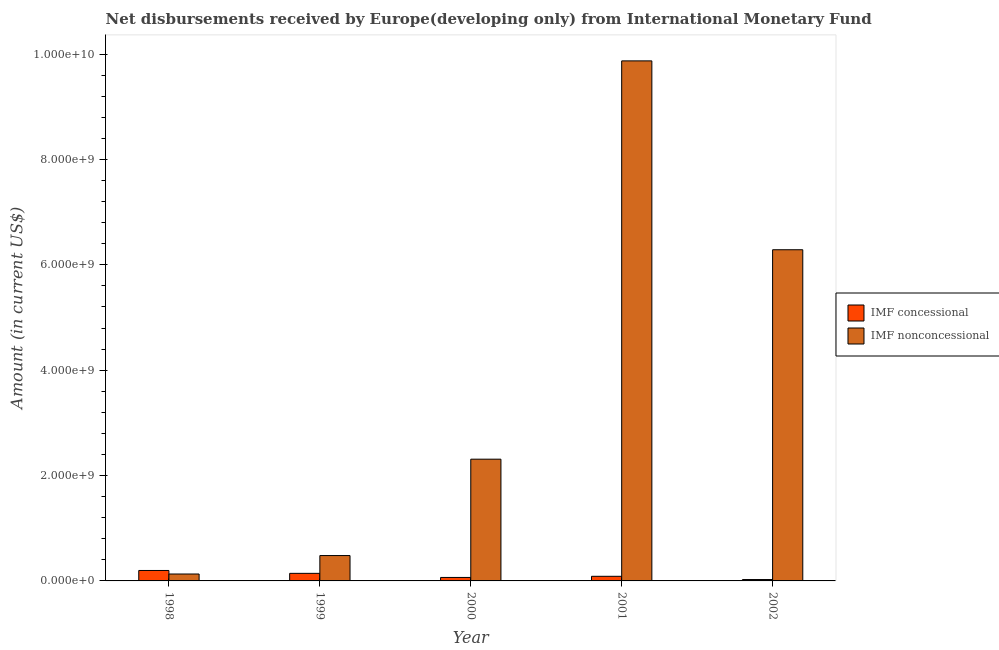How many groups of bars are there?
Your answer should be compact. 5. Are the number of bars per tick equal to the number of legend labels?
Keep it short and to the point. Yes. How many bars are there on the 2nd tick from the left?
Your answer should be compact. 2. What is the net concessional disbursements from imf in 2001?
Offer a terse response. 8.76e+07. Across all years, what is the maximum net concessional disbursements from imf?
Provide a short and direct response. 1.98e+08. Across all years, what is the minimum net concessional disbursements from imf?
Your answer should be very brief. 2.62e+07. In which year was the net non concessional disbursements from imf minimum?
Keep it short and to the point. 1998. What is the total net non concessional disbursements from imf in the graph?
Your answer should be very brief. 1.91e+1. What is the difference between the net concessional disbursements from imf in 2000 and that in 2001?
Ensure brevity in your answer.  -2.15e+07. What is the difference between the net non concessional disbursements from imf in 2001 and the net concessional disbursements from imf in 1998?
Offer a very short reply. 9.74e+09. What is the average net non concessional disbursements from imf per year?
Offer a very short reply. 3.82e+09. In how many years, is the net non concessional disbursements from imf greater than 6800000000 US$?
Keep it short and to the point. 1. What is the ratio of the net non concessional disbursements from imf in 1998 to that in 2002?
Provide a short and direct response. 0.02. Is the net concessional disbursements from imf in 1998 less than that in 2001?
Ensure brevity in your answer.  No. What is the difference between the highest and the second highest net concessional disbursements from imf?
Make the answer very short. 5.46e+07. What is the difference between the highest and the lowest net concessional disbursements from imf?
Offer a terse response. 1.72e+08. What does the 2nd bar from the left in 2002 represents?
Your response must be concise. IMF nonconcessional. What does the 1st bar from the right in 1998 represents?
Provide a short and direct response. IMF nonconcessional. How many bars are there?
Keep it short and to the point. 10. Are all the bars in the graph horizontal?
Your answer should be very brief. No. Are the values on the major ticks of Y-axis written in scientific E-notation?
Offer a terse response. Yes. Where does the legend appear in the graph?
Your answer should be compact. Center right. How many legend labels are there?
Provide a short and direct response. 2. What is the title of the graph?
Your response must be concise. Net disbursements received by Europe(developing only) from International Monetary Fund. What is the Amount (in current US$) in IMF concessional in 1998?
Your response must be concise. 1.98e+08. What is the Amount (in current US$) of IMF nonconcessional in 1998?
Make the answer very short. 1.31e+08. What is the Amount (in current US$) in IMF concessional in 1999?
Provide a short and direct response. 1.44e+08. What is the Amount (in current US$) in IMF nonconcessional in 1999?
Keep it short and to the point. 4.82e+08. What is the Amount (in current US$) in IMF concessional in 2000?
Keep it short and to the point. 6.60e+07. What is the Amount (in current US$) in IMF nonconcessional in 2000?
Provide a succinct answer. 2.31e+09. What is the Amount (in current US$) in IMF concessional in 2001?
Offer a terse response. 8.76e+07. What is the Amount (in current US$) of IMF nonconcessional in 2001?
Ensure brevity in your answer.  9.87e+09. What is the Amount (in current US$) of IMF concessional in 2002?
Offer a terse response. 2.62e+07. What is the Amount (in current US$) in IMF nonconcessional in 2002?
Provide a succinct answer. 6.29e+09. Across all years, what is the maximum Amount (in current US$) in IMF concessional?
Make the answer very short. 1.98e+08. Across all years, what is the maximum Amount (in current US$) of IMF nonconcessional?
Provide a short and direct response. 9.87e+09. Across all years, what is the minimum Amount (in current US$) in IMF concessional?
Make the answer very short. 2.62e+07. Across all years, what is the minimum Amount (in current US$) in IMF nonconcessional?
Provide a succinct answer. 1.31e+08. What is the total Amount (in current US$) in IMF concessional in the graph?
Offer a terse response. 5.22e+08. What is the total Amount (in current US$) in IMF nonconcessional in the graph?
Your answer should be very brief. 1.91e+1. What is the difference between the Amount (in current US$) in IMF concessional in 1998 and that in 1999?
Your response must be concise. 5.46e+07. What is the difference between the Amount (in current US$) of IMF nonconcessional in 1998 and that in 1999?
Your answer should be very brief. -3.50e+08. What is the difference between the Amount (in current US$) of IMF concessional in 1998 and that in 2000?
Ensure brevity in your answer.  1.32e+08. What is the difference between the Amount (in current US$) of IMF nonconcessional in 1998 and that in 2000?
Provide a short and direct response. -2.18e+09. What is the difference between the Amount (in current US$) of IMF concessional in 1998 and that in 2001?
Make the answer very short. 1.11e+08. What is the difference between the Amount (in current US$) in IMF nonconcessional in 1998 and that in 2001?
Your response must be concise. -9.74e+09. What is the difference between the Amount (in current US$) in IMF concessional in 1998 and that in 2002?
Offer a terse response. 1.72e+08. What is the difference between the Amount (in current US$) in IMF nonconcessional in 1998 and that in 2002?
Provide a succinct answer. -6.15e+09. What is the difference between the Amount (in current US$) of IMF concessional in 1999 and that in 2000?
Offer a terse response. 7.77e+07. What is the difference between the Amount (in current US$) of IMF nonconcessional in 1999 and that in 2000?
Your answer should be very brief. -1.83e+09. What is the difference between the Amount (in current US$) in IMF concessional in 1999 and that in 2001?
Your answer should be compact. 5.62e+07. What is the difference between the Amount (in current US$) in IMF nonconcessional in 1999 and that in 2001?
Ensure brevity in your answer.  -9.39e+09. What is the difference between the Amount (in current US$) of IMF concessional in 1999 and that in 2002?
Offer a terse response. 1.18e+08. What is the difference between the Amount (in current US$) in IMF nonconcessional in 1999 and that in 2002?
Ensure brevity in your answer.  -5.80e+09. What is the difference between the Amount (in current US$) in IMF concessional in 2000 and that in 2001?
Ensure brevity in your answer.  -2.15e+07. What is the difference between the Amount (in current US$) of IMF nonconcessional in 2000 and that in 2001?
Provide a short and direct response. -7.56e+09. What is the difference between the Amount (in current US$) in IMF concessional in 2000 and that in 2002?
Ensure brevity in your answer.  3.98e+07. What is the difference between the Amount (in current US$) of IMF nonconcessional in 2000 and that in 2002?
Your answer should be very brief. -3.97e+09. What is the difference between the Amount (in current US$) of IMF concessional in 2001 and that in 2002?
Give a very brief answer. 6.14e+07. What is the difference between the Amount (in current US$) of IMF nonconcessional in 2001 and that in 2002?
Ensure brevity in your answer.  3.58e+09. What is the difference between the Amount (in current US$) of IMF concessional in 1998 and the Amount (in current US$) of IMF nonconcessional in 1999?
Provide a succinct answer. -2.83e+08. What is the difference between the Amount (in current US$) of IMF concessional in 1998 and the Amount (in current US$) of IMF nonconcessional in 2000?
Ensure brevity in your answer.  -2.11e+09. What is the difference between the Amount (in current US$) in IMF concessional in 1998 and the Amount (in current US$) in IMF nonconcessional in 2001?
Provide a succinct answer. -9.67e+09. What is the difference between the Amount (in current US$) in IMF concessional in 1998 and the Amount (in current US$) in IMF nonconcessional in 2002?
Give a very brief answer. -6.09e+09. What is the difference between the Amount (in current US$) in IMF concessional in 1999 and the Amount (in current US$) in IMF nonconcessional in 2000?
Offer a very short reply. -2.17e+09. What is the difference between the Amount (in current US$) of IMF concessional in 1999 and the Amount (in current US$) of IMF nonconcessional in 2001?
Offer a very short reply. -9.73e+09. What is the difference between the Amount (in current US$) of IMF concessional in 1999 and the Amount (in current US$) of IMF nonconcessional in 2002?
Ensure brevity in your answer.  -6.14e+09. What is the difference between the Amount (in current US$) of IMF concessional in 2000 and the Amount (in current US$) of IMF nonconcessional in 2001?
Offer a terse response. -9.80e+09. What is the difference between the Amount (in current US$) in IMF concessional in 2000 and the Amount (in current US$) in IMF nonconcessional in 2002?
Keep it short and to the point. -6.22e+09. What is the difference between the Amount (in current US$) of IMF concessional in 2001 and the Amount (in current US$) of IMF nonconcessional in 2002?
Your response must be concise. -6.20e+09. What is the average Amount (in current US$) of IMF concessional per year?
Offer a very short reply. 1.04e+08. What is the average Amount (in current US$) in IMF nonconcessional per year?
Offer a terse response. 3.82e+09. In the year 1998, what is the difference between the Amount (in current US$) in IMF concessional and Amount (in current US$) in IMF nonconcessional?
Provide a succinct answer. 6.71e+07. In the year 1999, what is the difference between the Amount (in current US$) in IMF concessional and Amount (in current US$) in IMF nonconcessional?
Offer a very short reply. -3.38e+08. In the year 2000, what is the difference between the Amount (in current US$) in IMF concessional and Amount (in current US$) in IMF nonconcessional?
Your response must be concise. -2.24e+09. In the year 2001, what is the difference between the Amount (in current US$) in IMF concessional and Amount (in current US$) in IMF nonconcessional?
Ensure brevity in your answer.  -9.78e+09. In the year 2002, what is the difference between the Amount (in current US$) of IMF concessional and Amount (in current US$) of IMF nonconcessional?
Keep it short and to the point. -6.26e+09. What is the ratio of the Amount (in current US$) in IMF concessional in 1998 to that in 1999?
Ensure brevity in your answer.  1.38. What is the ratio of the Amount (in current US$) in IMF nonconcessional in 1998 to that in 1999?
Provide a short and direct response. 0.27. What is the ratio of the Amount (in current US$) in IMF concessional in 1998 to that in 2000?
Your answer should be very brief. 3. What is the ratio of the Amount (in current US$) in IMF nonconcessional in 1998 to that in 2000?
Give a very brief answer. 0.06. What is the ratio of the Amount (in current US$) of IMF concessional in 1998 to that in 2001?
Provide a short and direct response. 2.27. What is the ratio of the Amount (in current US$) in IMF nonconcessional in 1998 to that in 2001?
Your answer should be very brief. 0.01. What is the ratio of the Amount (in current US$) in IMF concessional in 1998 to that in 2002?
Provide a succinct answer. 7.57. What is the ratio of the Amount (in current US$) in IMF nonconcessional in 1998 to that in 2002?
Your response must be concise. 0.02. What is the ratio of the Amount (in current US$) in IMF concessional in 1999 to that in 2000?
Your response must be concise. 2.18. What is the ratio of the Amount (in current US$) in IMF nonconcessional in 1999 to that in 2000?
Provide a succinct answer. 0.21. What is the ratio of the Amount (in current US$) of IMF concessional in 1999 to that in 2001?
Your answer should be compact. 1.64. What is the ratio of the Amount (in current US$) in IMF nonconcessional in 1999 to that in 2001?
Offer a very short reply. 0.05. What is the ratio of the Amount (in current US$) of IMF concessional in 1999 to that in 2002?
Offer a very short reply. 5.48. What is the ratio of the Amount (in current US$) in IMF nonconcessional in 1999 to that in 2002?
Provide a succinct answer. 0.08. What is the ratio of the Amount (in current US$) of IMF concessional in 2000 to that in 2001?
Provide a succinct answer. 0.75. What is the ratio of the Amount (in current US$) in IMF nonconcessional in 2000 to that in 2001?
Provide a short and direct response. 0.23. What is the ratio of the Amount (in current US$) in IMF concessional in 2000 to that in 2002?
Offer a terse response. 2.52. What is the ratio of the Amount (in current US$) of IMF nonconcessional in 2000 to that in 2002?
Provide a succinct answer. 0.37. What is the ratio of the Amount (in current US$) in IMF concessional in 2001 to that in 2002?
Ensure brevity in your answer.  3.34. What is the ratio of the Amount (in current US$) of IMF nonconcessional in 2001 to that in 2002?
Your response must be concise. 1.57. What is the difference between the highest and the second highest Amount (in current US$) of IMF concessional?
Your response must be concise. 5.46e+07. What is the difference between the highest and the second highest Amount (in current US$) in IMF nonconcessional?
Provide a succinct answer. 3.58e+09. What is the difference between the highest and the lowest Amount (in current US$) of IMF concessional?
Make the answer very short. 1.72e+08. What is the difference between the highest and the lowest Amount (in current US$) of IMF nonconcessional?
Provide a succinct answer. 9.74e+09. 